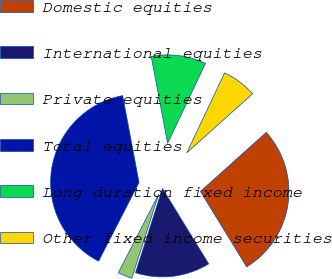<chart> <loc_0><loc_0><loc_500><loc_500><pie_chart><fcel>Domestic equities<fcel>International equities<fcel>Private equities<fcel>Total equities<fcel>Long duration fixed income<fcel>Other fixed income securities<nl><fcel>27.89%<fcel>13.68%<fcel>2.63%<fcel>39.47%<fcel>10.0%<fcel>6.32%<nl></chart> 